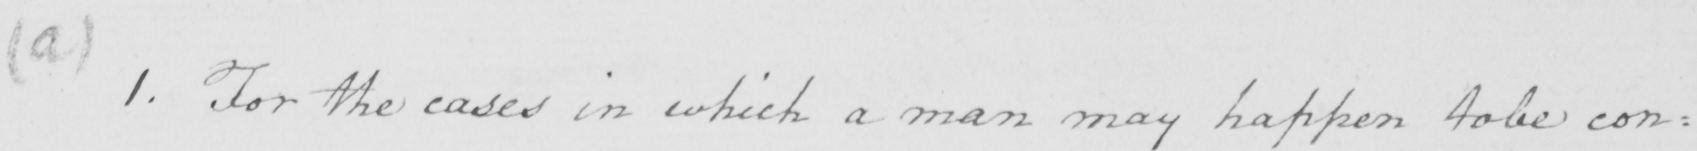Please transcribe the handwritten text in this image. ( a )  1 . For the cases in which a man may happen to be con= 